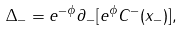Convert formula to latex. <formula><loc_0><loc_0><loc_500><loc_500>\Delta _ { - } = e ^ { - \phi } \partial _ { - } [ e ^ { \phi } C ^ { - } ( x _ { - } ) ] ,</formula> 